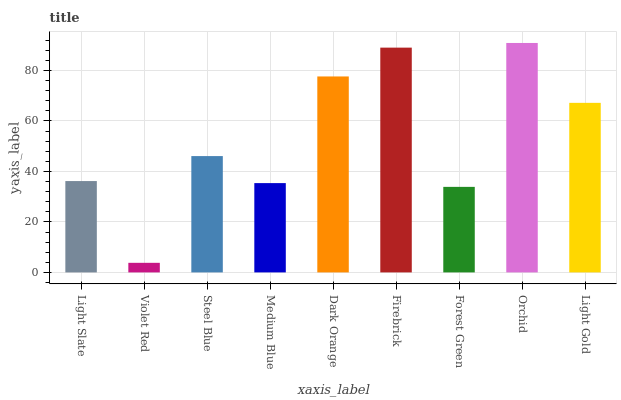Is Steel Blue the minimum?
Answer yes or no. No. Is Steel Blue the maximum?
Answer yes or no. No. Is Steel Blue greater than Violet Red?
Answer yes or no. Yes. Is Violet Red less than Steel Blue?
Answer yes or no. Yes. Is Violet Red greater than Steel Blue?
Answer yes or no. No. Is Steel Blue less than Violet Red?
Answer yes or no. No. Is Steel Blue the high median?
Answer yes or no. Yes. Is Steel Blue the low median?
Answer yes or no. Yes. Is Dark Orange the high median?
Answer yes or no. No. Is Medium Blue the low median?
Answer yes or no. No. 